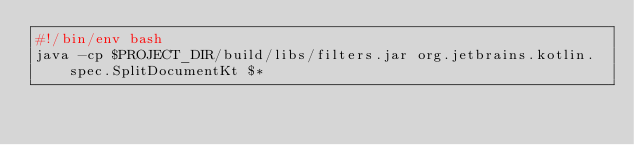<code> <loc_0><loc_0><loc_500><loc_500><_Bash_>#!/bin/env bash
java -cp $PROJECT_DIR/build/libs/filters.jar org.jetbrains.kotlin.spec.SplitDocumentKt $*
</code> 